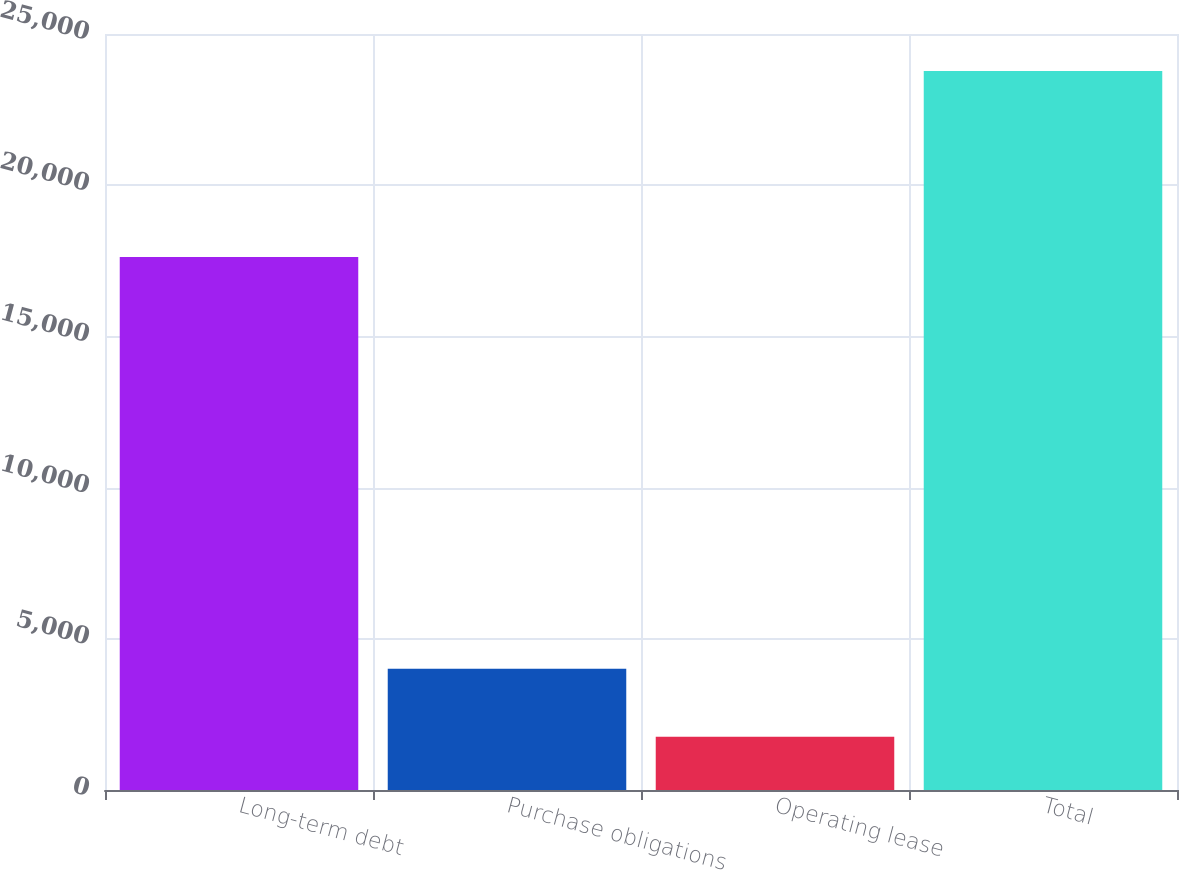<chart> <loc_0><loc_0><loc_500><loc_500><bar_chart><fcel>Long-term debt<fcel>Purchase obligations<fcel>Operating lease<fcel>Total<nl><fcel>17627<fcel>4013<fcel>1758<fcel>23773<nl></chart> 